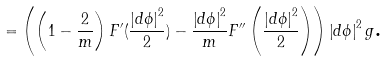Convert formula to latex. <formula><loc_0><loc_0><loc_500><loc_500>= \left ( \left ( 1 - \frac { 2 } { m } \right ) F ^ { \prime } ( \frac { \left | d \phi \right | ^ { 2 } } { 2 } ) - \frac { \left | d \phi \right | ^ { 2 } } { m } F ^ { \prime \prime } \left ( \frac { \left | d \phi \right | ^ { 2 } } { 2 } \right ) \right ) \left | d \phi \right | ^ { 2 } g \text {.}</formula> 